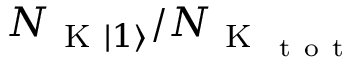Convert formula to latex. <formula><loc_0><loc_0><loc_500><loc_500>N _ { K | 1 \rangle } / N _ { K _ { t o t } }</formula> 